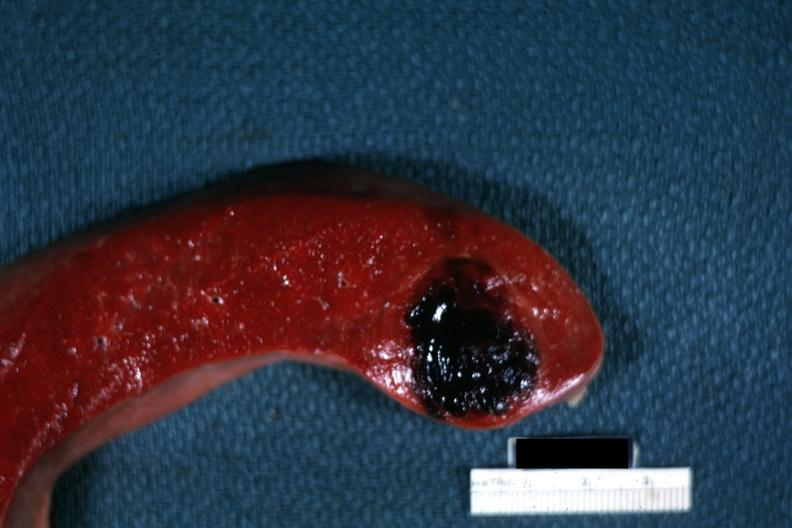s spleen present?
Answer the question using a single word or phrase. Yes 